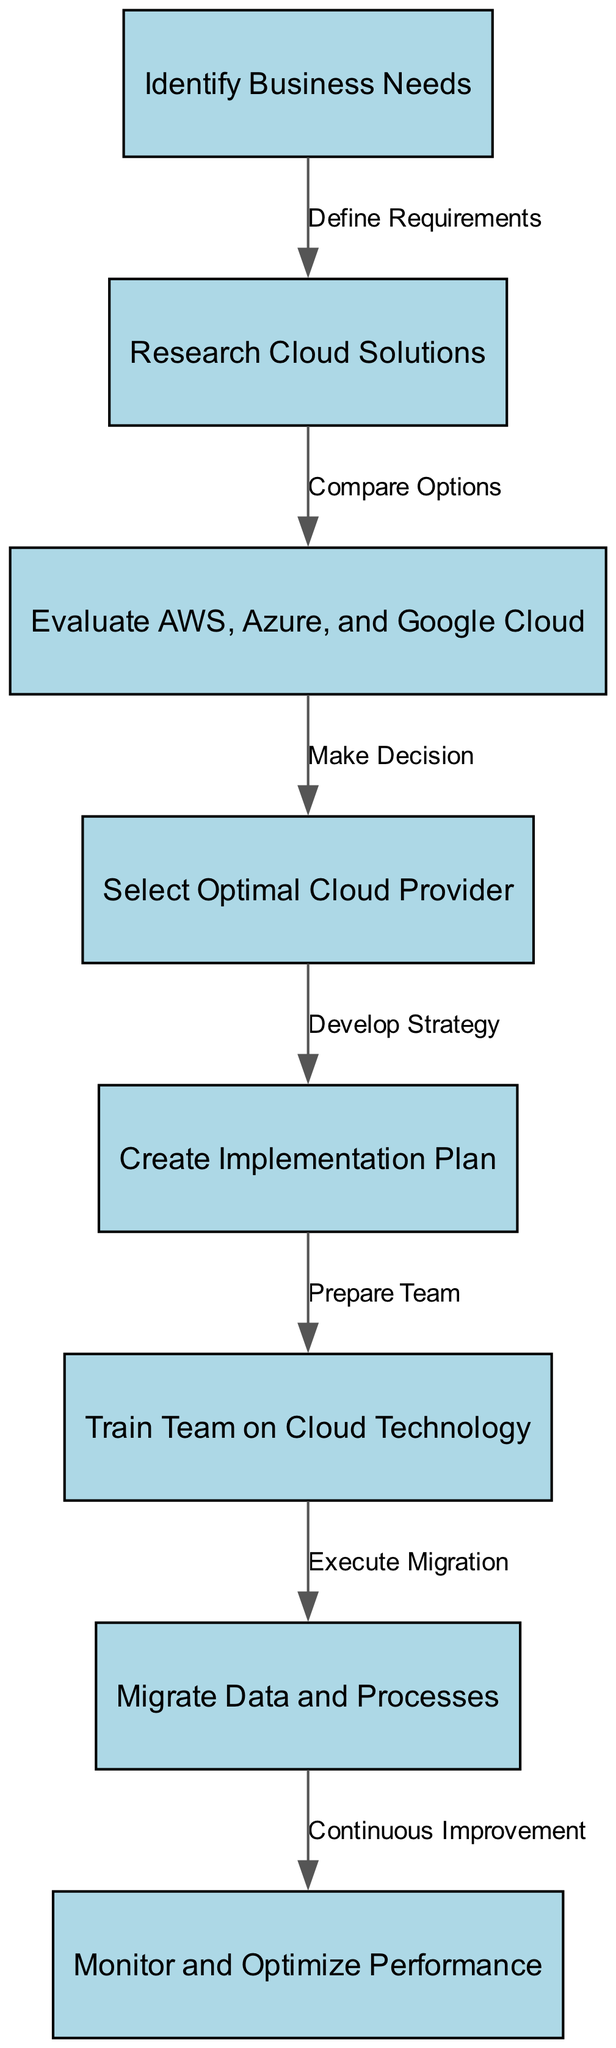What is the first step in the adoption process? The first step is indicated as "Identify Business Needs," which is the starting node in the flowchart.
Answer: Identify Business Needs How many nodes are present in the diagram? The diagram has a total of eight nodes as listed in the data provided.
Answer: Eight Which node follows "Evaluate AWS, Azure, and Google Cloud"? The node that follows "Evaluate AWS, Azure, and Google Cloud" is "Select Optimal Cloud Provider."
Answer: Select Optimal Cloud Provider What is the label of the edge that connects "Create Implementation Plan" to another node? The label of the edge leading from "Create Implementation Plan" to "Train Team on Cloud Technology" is "Prepare Team."
Answer: Prepare Team What is the relationship between "Migrate Data and Processes" and "Monitor and Optimize Performance"? "Migrate Data and Processes" leads to "Monitor and Optimize Performance," and this edge is labeled "Continuous Improvement."
Answer: Continuous Improvement What is the last step in the adoption process? The last step in the flowchart is "Monitor and Optimize Performance," indicating it is the concluding phase of the process.
Answer: Monitor and Optimize Performance What decision follows after "Research Cloud Solutions"? The decision that follows "Research Cloud Solutions" is to "Evaluate AWS, Azure, and Google Cloud."
Answer: Evaluate AWS, Azure, and Google Cloud In how many stages does the adoption process occur according to the diagram? The adoption process occurs in seven stages based on the flow from identifying needs to monitoring performance.
Answer: Seven 